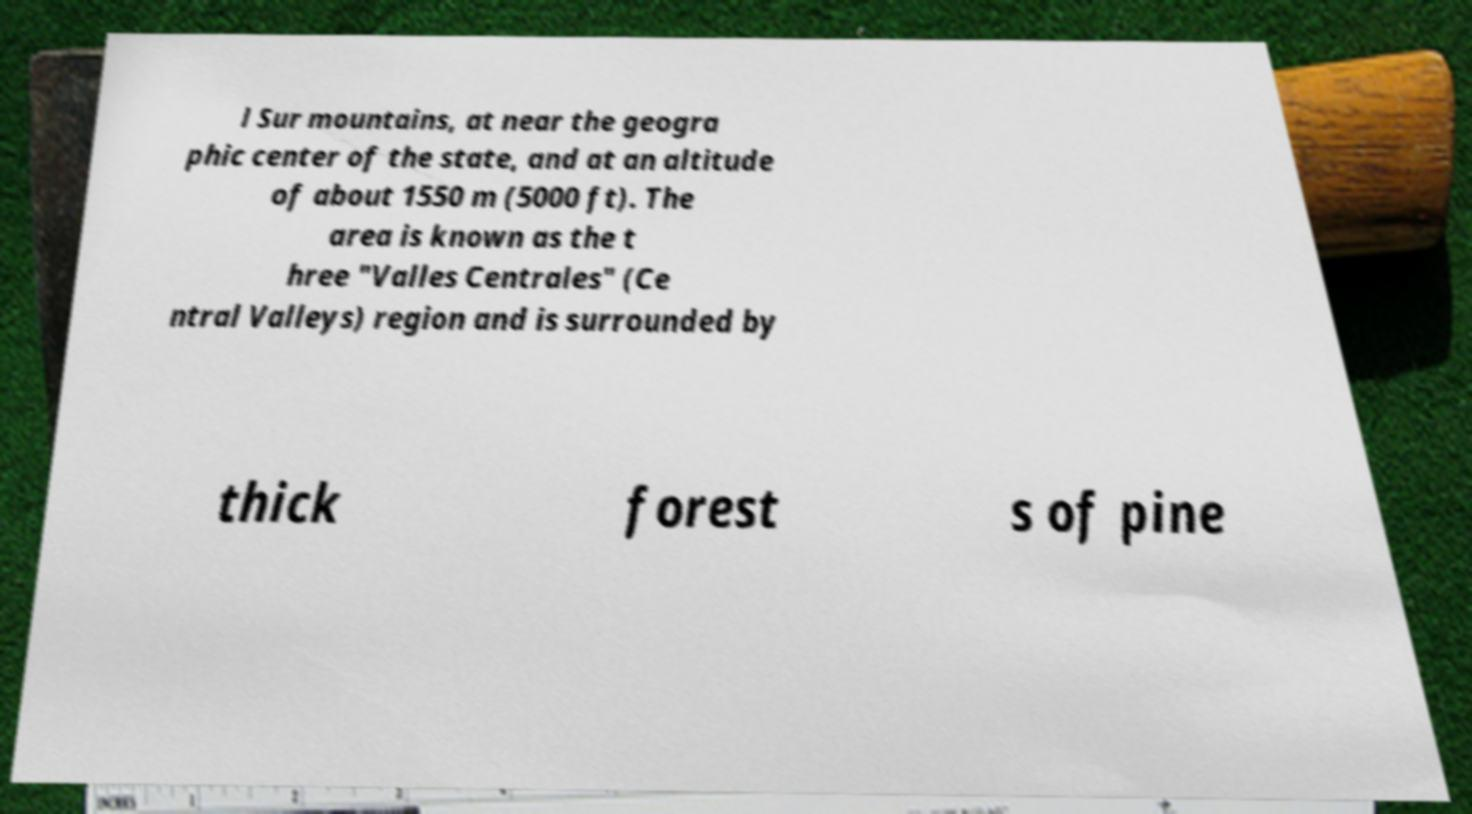Please identify and transcribe the text found in this image. l Sur mountains, at near the geogra phic center of the state, and at an altitude of about 1550 m (5000 ft). The area is known as the t hree "Valles Centrales" (Ce ntral Valleys) region and is surrounded by thick forest s of pine 